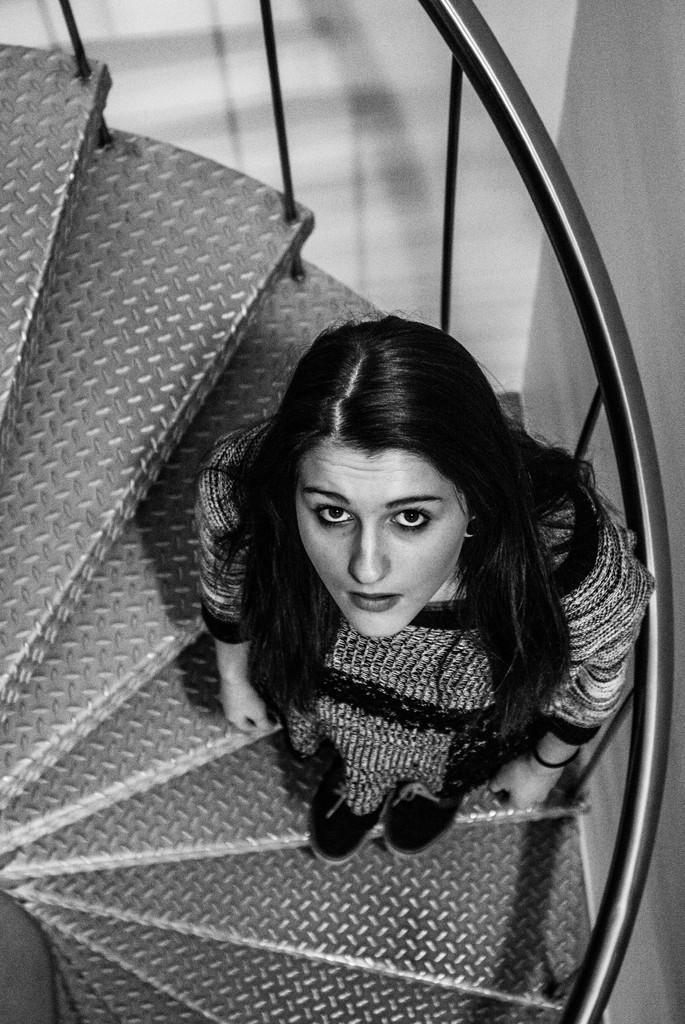Who is the main subject in the image? There is a girl in the image. Where is the girl located in the image? The girl is in the center of the image. What is the girl doing in the image? The girl is on the stairs. How much wealth does the kitten have in the image? There is no kitten present in the image, so it is not possible to determine its wealth. 